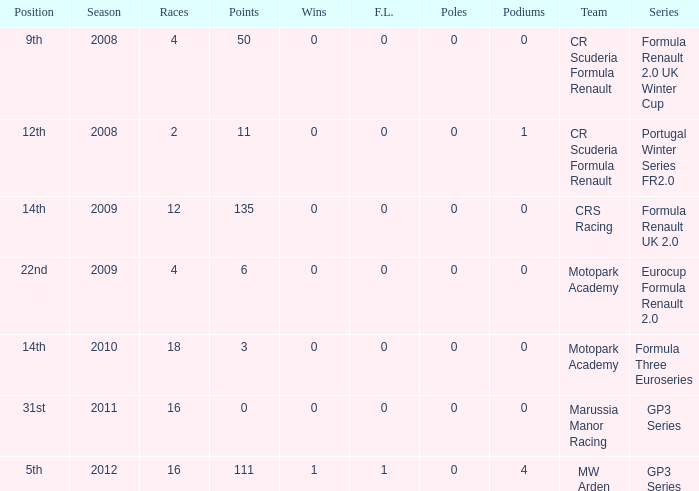How many F.L. are listed for Formula Three Euroseries? 1.0. 